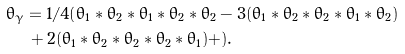Convert formula to latex. <formula><loc_0><loc_0><loc_500><loc_500>\theta _ { \gamma } & = 1 / 4 ( \theta _ { 1 } * \theta _ { 2 } * \theta _ { 1 } * \theta _ { 2 } * \theta _ { 2 } - 3 ( \theta _ { 1 } * \theta _ { 2 } * \theta _ { 2 } * \theta _ { 1 } * \theta _ { 2 } ) \\ & \, + 2 ( \theta _ { 1 } * \theta _ { 2 } * \theta _ { 2 } * \theta _ { 2 } * \theta _ { 1 } ) + ) .</formula> 